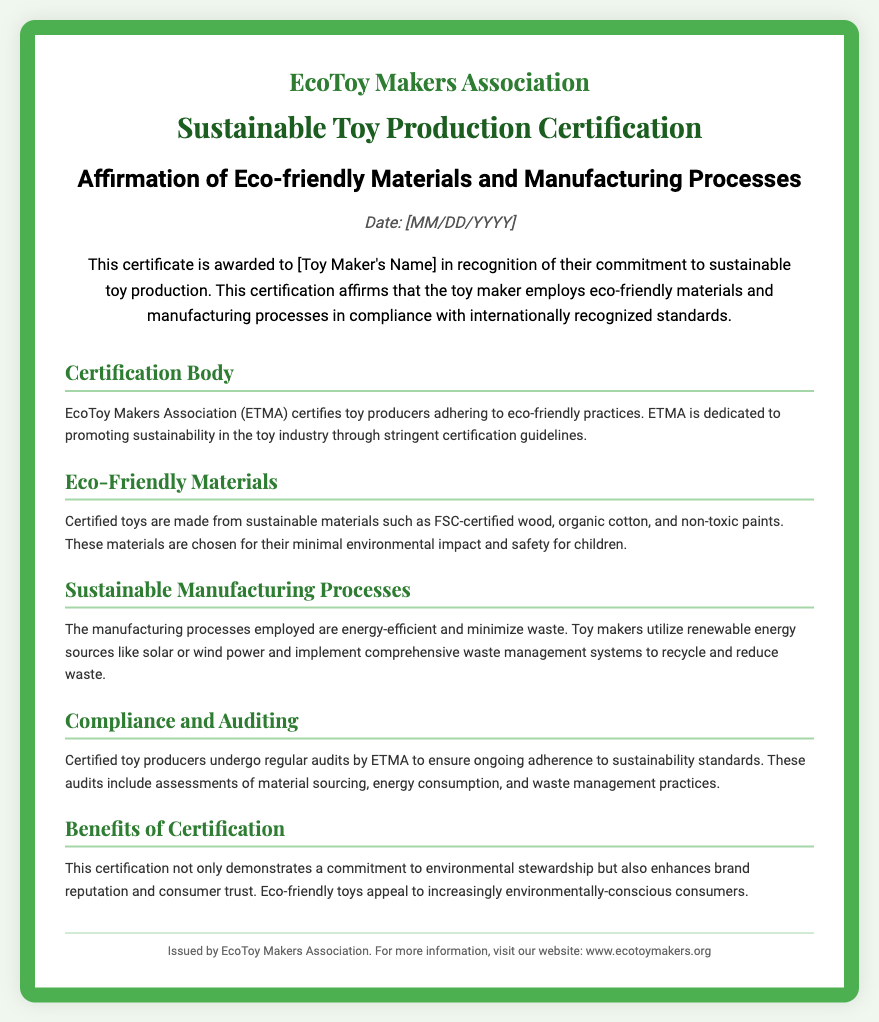What is the name of the certification body? The certification body mentioned in the document is responsible for overseeing eco-friendly toy production.
Answer: EcoToy Makers Association What is the date format used in the document? The document provides a placeholder for the date in a specific format.
Answer: MM/DD/YYYY What materials are certified toys made from? The document specifies types of sustainable materials that certified toys are made from.
Answer: FSC-certified wood, organic cotton, and non-toxic paints How often do producers undergo audits? The document states that producers must undergo evaluations to maintain their certification status.
Answer: Regularly What is one benefit of certification mentioned in the document? The document lists a key advantage of obtaining this certification for toy makers.
Answer: Enhanced brand reputation What does ETMA stand for? The abbreviation ETMA is used in the document, indicating the name of the certification organization.
Answer: EcoToy Makers Association What is emphasized as important for eco-friendly toys? The document highlights the significance of a particular aspect related to eco-friendly toys.
Answer: Minimal environmental impact Which energy sources are mentioned as sustainable in manufacturing? The document specifies types of energy sources that certified toy makers should use.
Answer: Solar or wind power 